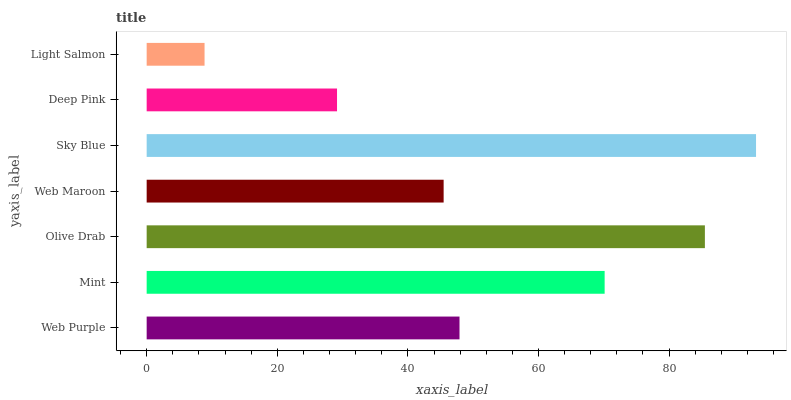Is Light Salmon the minimum?
Answer yes or no. Yes. Is Sky Blue the maximum?
Answer yes or no. Yes. Is Mint the minimum?
Answer yes or no. No. Is Mint the maximum?
Answer yes or no. No. Is Mint greater than Web Purple?
Answer yes or no. Yes. Is Web Purple less than Mint?
Answer yes or no. Yes. Is Web Purple greater than Mint?
Answer yes or no. No. Is Mint less than Web Purple?
Answer yes or no. No. Is Web Purple the high median?
Answer yes or no. Yes. Is Web Purple the low median?
Answer yes or no. Yes. Is Mint the high median?
Answer yes or no. No. Is Olive Drab the low median?
Answer yes or no. No. 